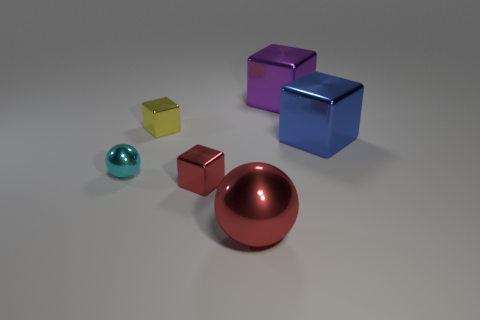Which objects would you say have reflective surfaces? The objects with reflective surfaces in the image are the large red sphere and the teal-colored sphere, both appear to have a shiny finish that reflects light.  Are there any objects that are identical? No, all of the objects in the image are unique in terms of size, shape, or color; there are no identical objects. 